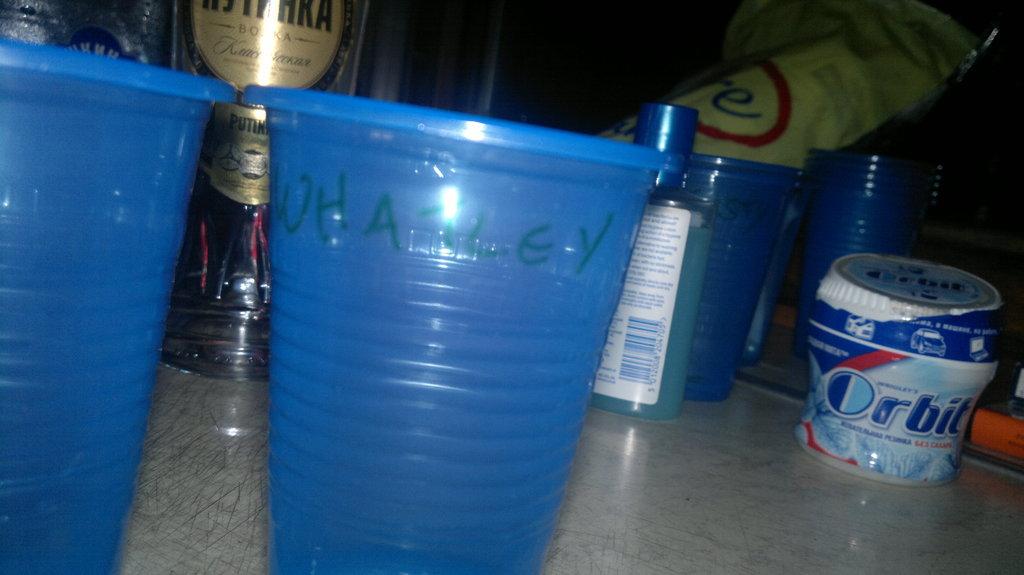Who does the cup belong to?
Keep it short and to the point. Whatley. What kind of gum in on the table?
Your response must be concise. Orbit. 